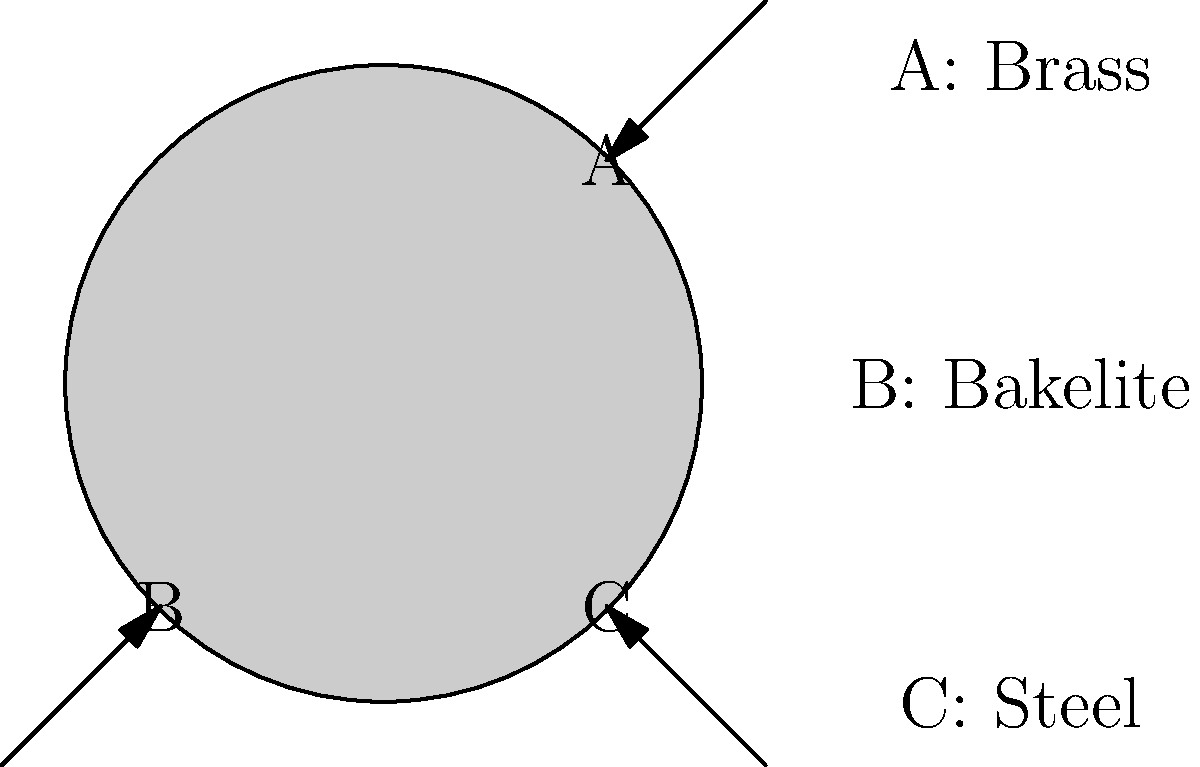Based on the close-up photograph of a vintage fishing reel, which material is most likely used for the main body (area B) of the reel? To identify the material composition of a vintage fishing reel from a close-up photograph, we need to consider the following steps:

1. Observe the appearance: Bakelite, a type of early plastic, has a distinctive dark brown or black color with a slightly mottled or swirled appearance.

2. Consider the era: Bakelite was widely used in the manufacturing of fishing reels from the 1930s to the 1950s.

3. Examine the texture: Bakelite often has a smooth, slightly glossy surface that may show signs of age-related crazing or fine cracks.

4. Compare with other materials:
   - Brass (area A) typically has a golden color and may show patina or tarnish.
   - Steel (area C) usually has a silvery-gray color and may show signs of rust or corrosion.

5. Assess the manufacturing process: Bakelite parts are often molded, which allows for more complex shapes compared to machined metal parts.

6. Consider weight: Bakelite is lighter than brass or steel, which made it popular for reel bodies to reduce overall weight.

Given the dark color, smooth appearance, and its use for the main body of the reel, the material in area B is most likely Bakelite.
Answer: Bakelite 